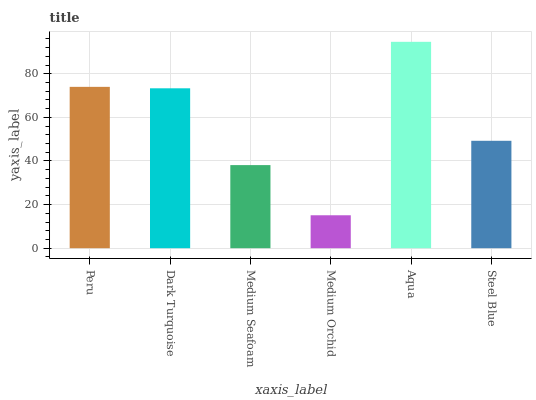Is Dark Turquoise the minimum?
Answer yes or no. No. Is Dark Turquoise the maximum?
Answer yes or no. No. Is Peru greater than Dark Turquoise?
Answer yes or no. Yes. Is Dark Turquoise less than Peru?
Answer yes or no. Yes. Is Dark Turquoise greater than Peru?
Answer yes or no. No. Is Peru less than Dark Turquoise?
Answer yes or no. No. Is Dark Turquoise the high median?
Answer yes or no. Yes. Is Steel Blue the low median?
Answer yes or no. Yes. Is Medium Orchid the high median?
Answer yes or no. No. Is Medium Orchid the low median?
Answer yes or no. No. 